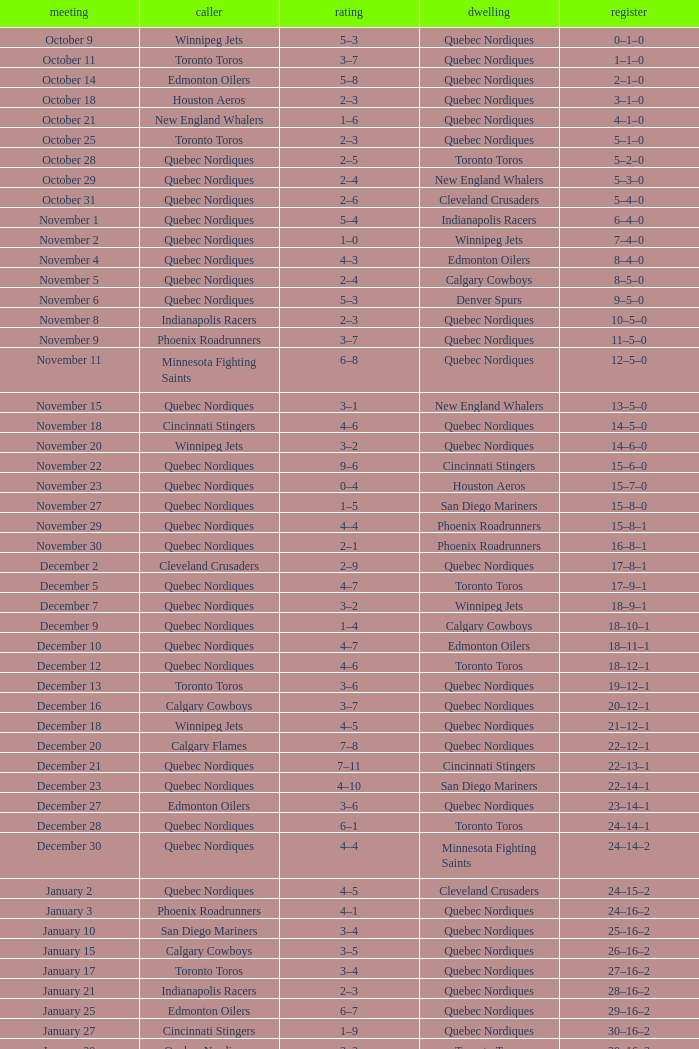What was the date of the game with a score of 2–1? November 30. 